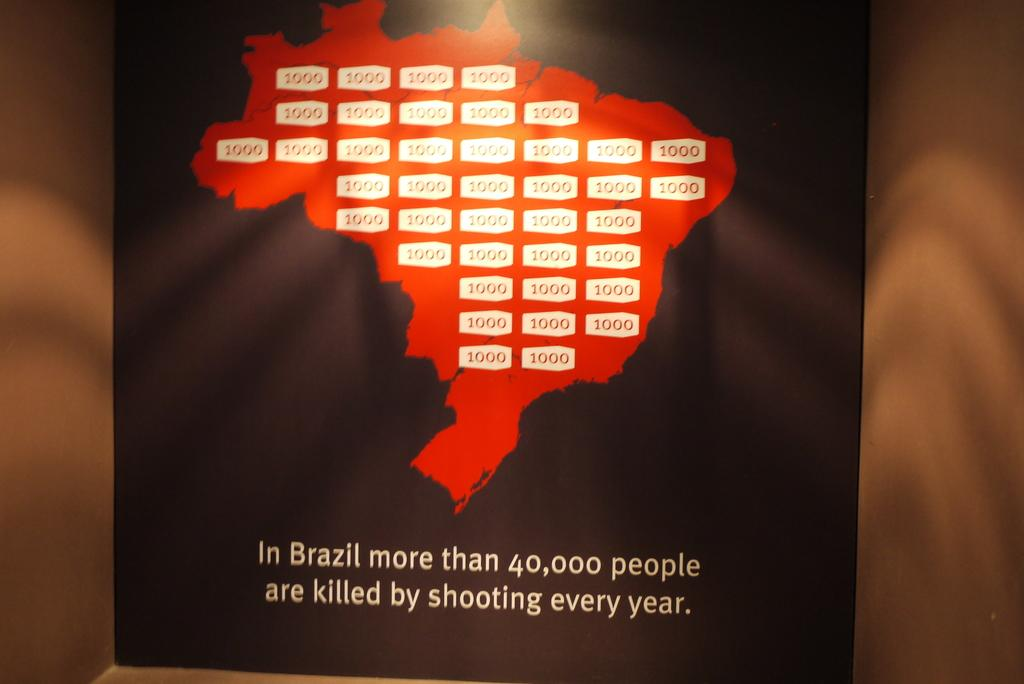<image>
Give a short and clear explanation of the subsequent image. Black sign on a wall that says there are more than 40,000 people dying each year in Brazil. 